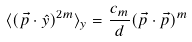Convert formula to latex. <formula><loc_0><loc_0><loc_500><loc_500>\langle ( { \vec { p } } \cdot { \hat { y } } ) ^ { 2 m } \rangle _ { y } = \frac { c _ { m } } { d } ( { \vec { p } } \cdot { \vec { p } } ) ^ { m }</formula> 